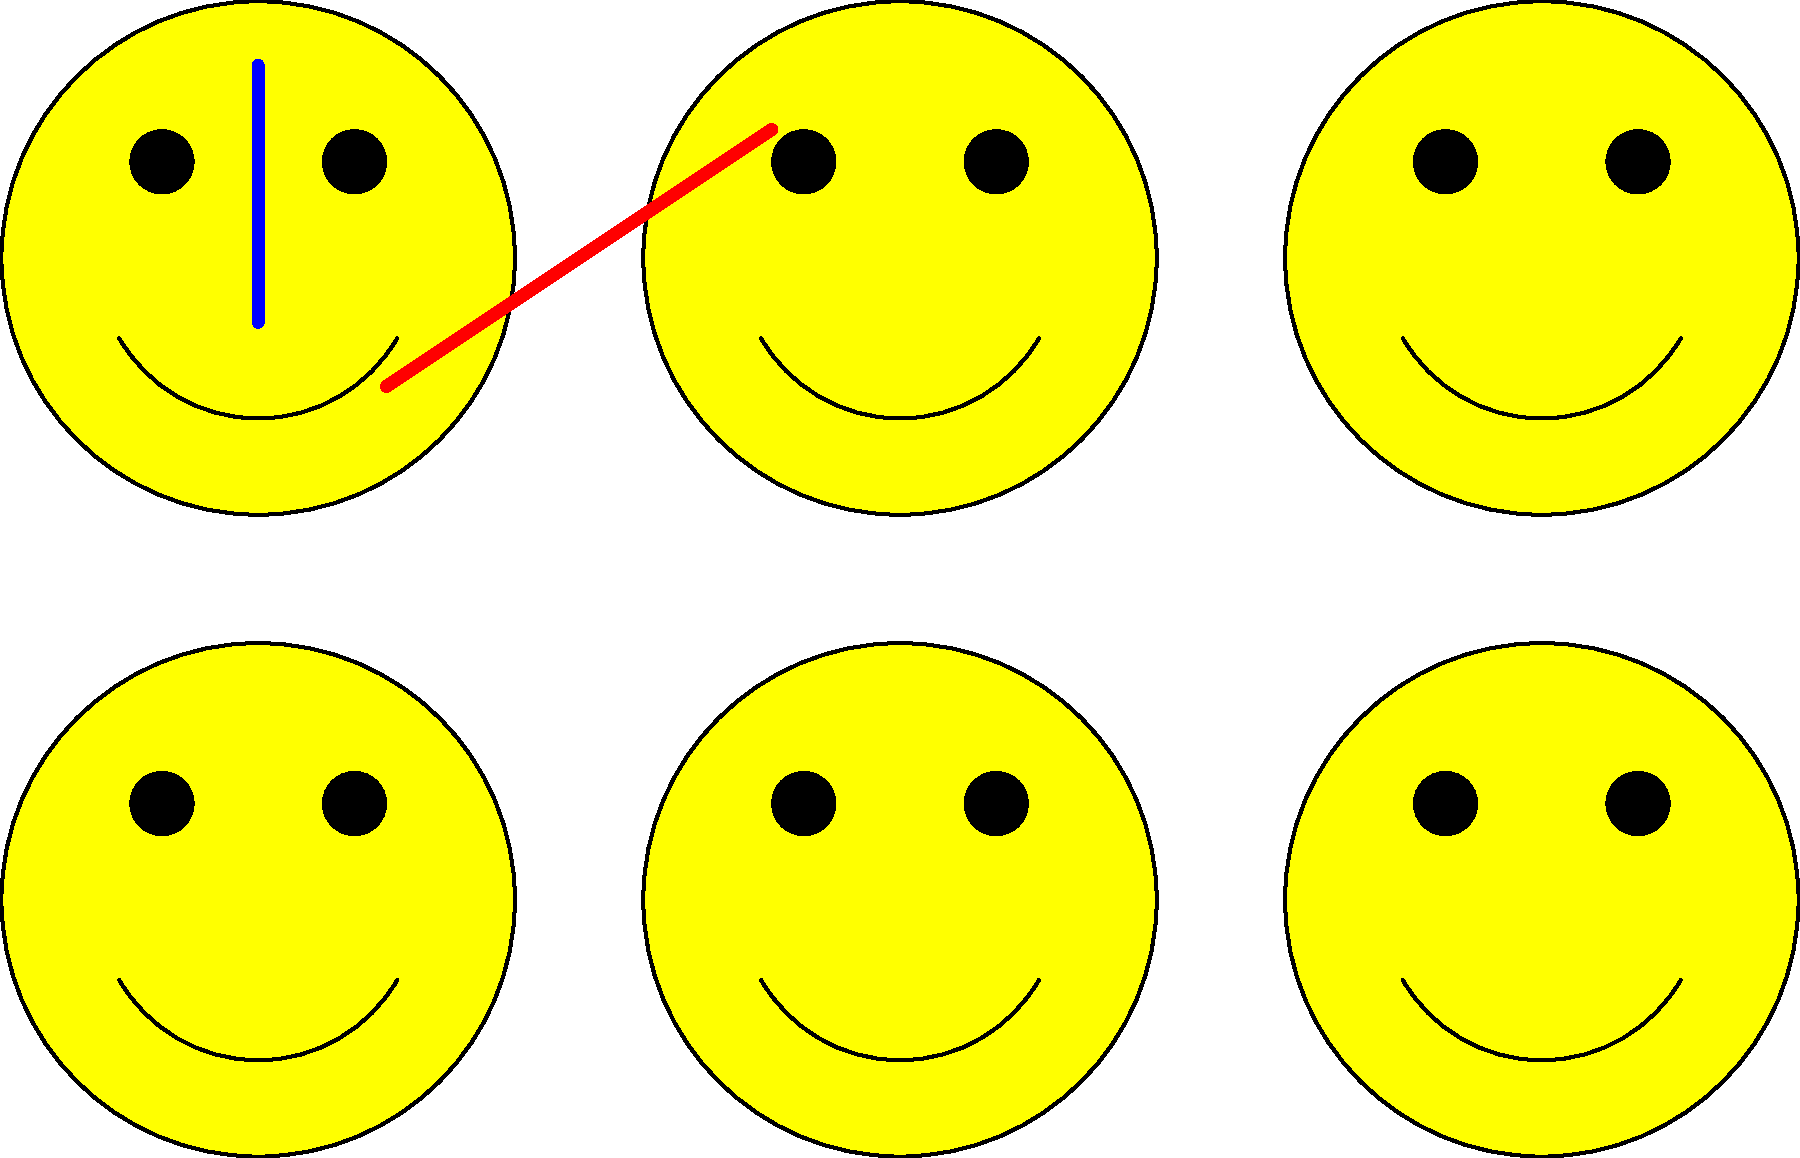Interpret the series of emojis above and match them to their corresponding metaphors from classic literature. Which famous work is represented by the emoji with the sword? Let's analyze each emoji and its potential literary metaphor:

1. Emoji with a sword: This likely represents "Hamlet" by William Shakespeare. The sword symbolizes Hamlet's inner conflict and the famous "To be or not to be" soliloquy.

2. Emoji with a red X: This could represent "The Scarlet Letter" by Nathaniel Hawthorne, where the red 'A' is a central symbol.

3. Emoji with a green triangle: This might represent "The Great Gatsby" by F. Scott Fitzgerald, with the green light symbolizing Gatsby's dreams and hopes.

4. Emoji with a tree: This could represent "The Giving Tree" by Shel Silverstein, symbolizing selfless love and sacrifice.

5. Emoji with a clock hand: This likely represents "The Time Machine" by H.G. Wells, symbolizing the concept of time travel.

6. Emoji with a target: This could represent "The Catcher in the Rye" by J.D. Salinger, symbolizing Holden's desire to protect innocence.

The question specifically asks about the emoji with the sword, which we've identified as representing "Hamlet" by William Shakespeare.
Answer: Hamlet 